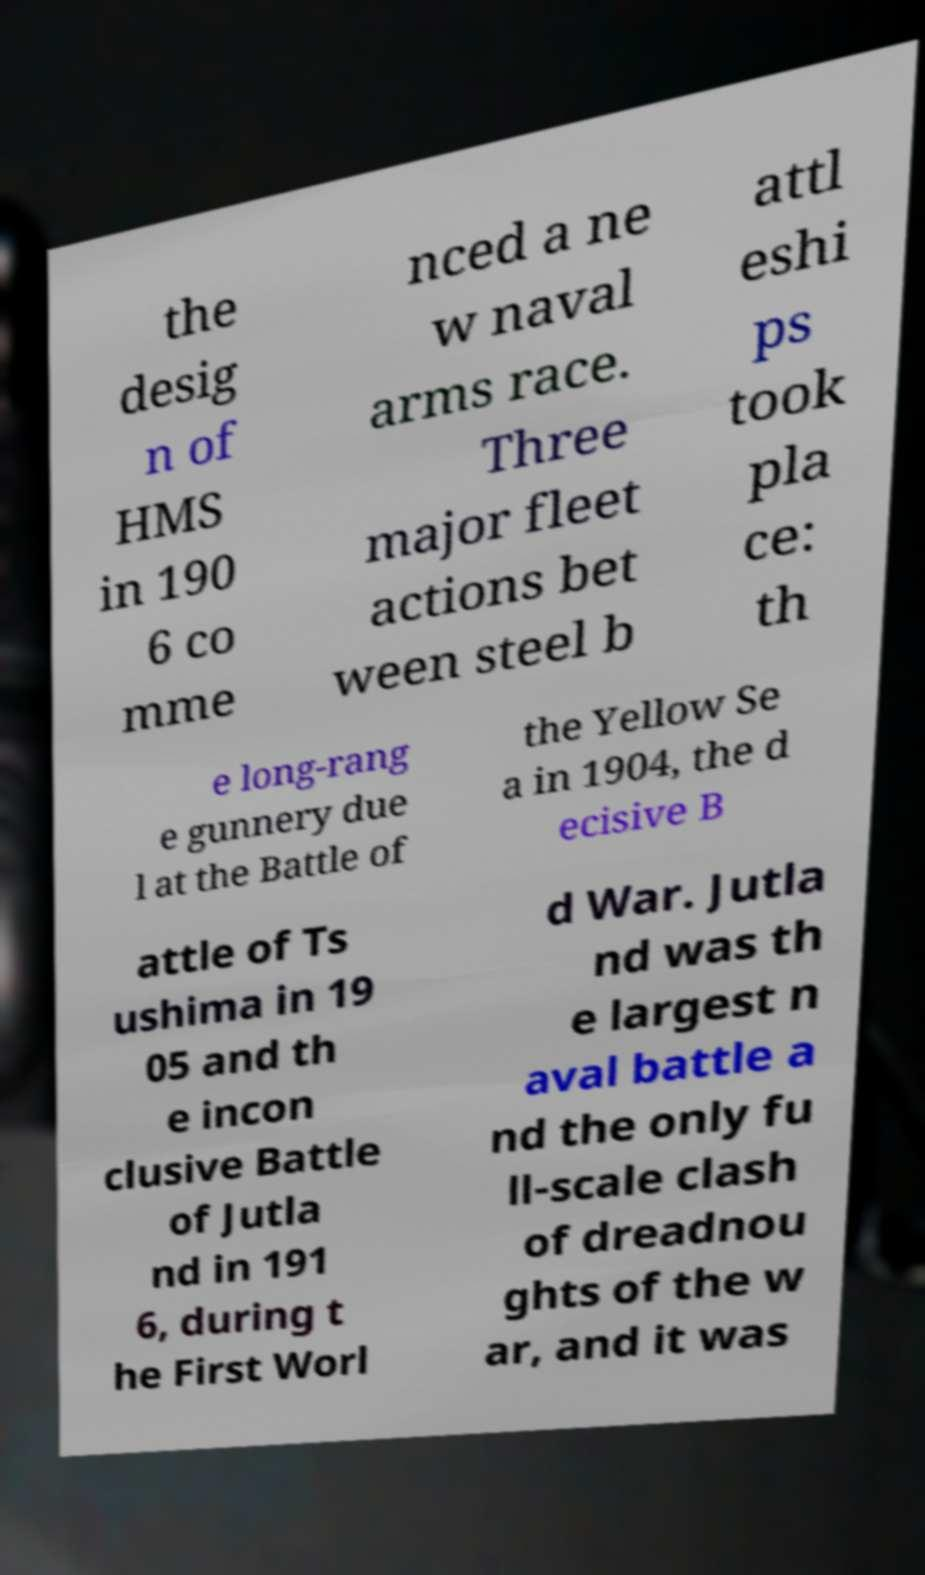Can you accurately transcribe the text from the provided image for me? the desig n of HMS in 190 6 co mme nced a ne w naval arms race. Three major fleet actions bet ween steel b attl eshi ps took pla ce: th e long-rang e gunnery due l at the Battle of the Yellow Se a in 1904, the d ecisive B attle of Ts ushima in 19 05 and th e incon clusive Battle of Jutla nd in 191 6, during t he First Worl d War. Jutla nd was th e largest n aval battle a nd the only fu ll-scale clash of dreadnou ghts of the w ar, and it was 